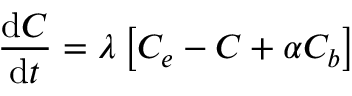Convert formula to latex. <formula><loc_0><loc_0><loc_500><loc_500>\frac { d C } { d t } = \lambda \left [ C _ { e } - C + \alpha C _ { b } \right ]</formula> 